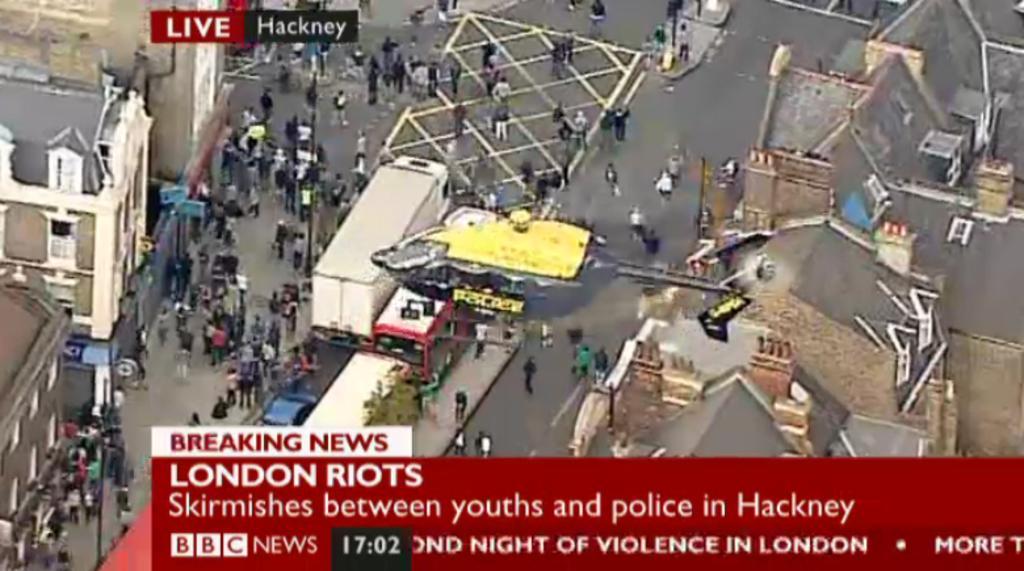Describe this image in one or two sentences. In this image we can see few buildings, there are some vehicles and poles, also we can see a few people on the road, at the bottom of the image we can see the text. 